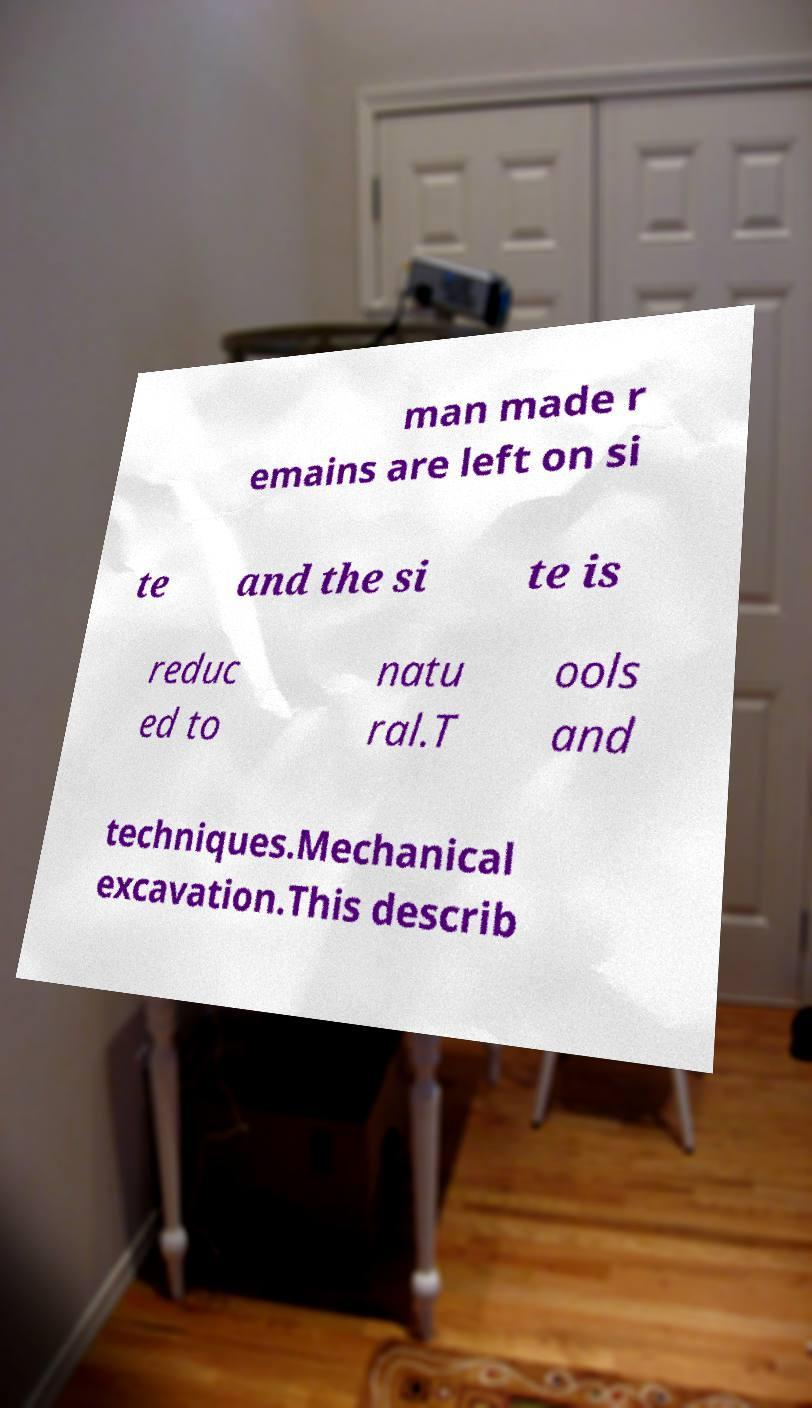Could you extract and type out the text from this image? man made r emains are left on si te and the si te is reduc ed to natu ral.T ools and techniques.Mechanical excavation.This describ 